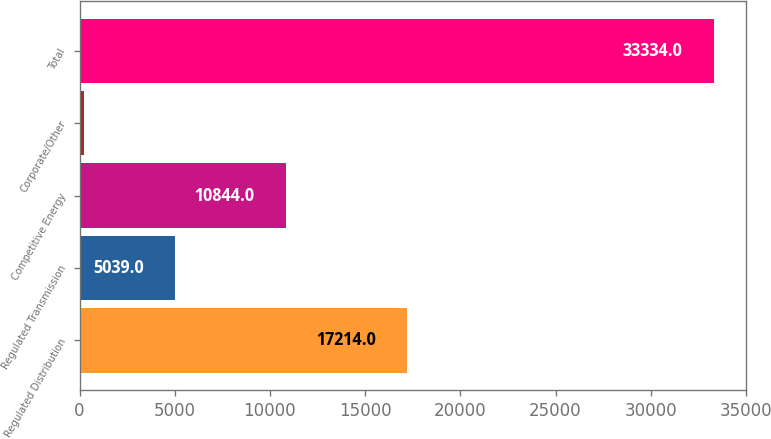Convert chart. <chart><loc_0><loc_0><loc_500><loc_500><bar_chart><fcel>Regulated Distribution<fcel>Regulated Transmission<fcel>Competitive Energy<fcel>Corporate/Other<fcel>Total<nl><fcel>17214<fcel>5039<fcel>10844<fcel>237<fcel>33334<nl></chart> 